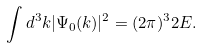<formula> <loc_0><loc_0><loc_500><loc_500>\int d ^ { 3 } k | \Psi _ { 0 } ( k ) | ^ { 2 } = ( 2 \pi ) ^ { 3 } 2 E .</formula> 